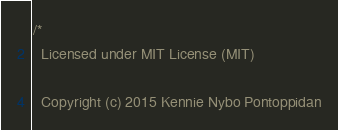Convert code to text. <code><loc_0><loc_0><loc_500><loc_500><_SQL_>/* 
  Licensed under MIT License (MIT)

  Copyright (c) 2015 Kennie Nybo Pontoppidan
</code> 